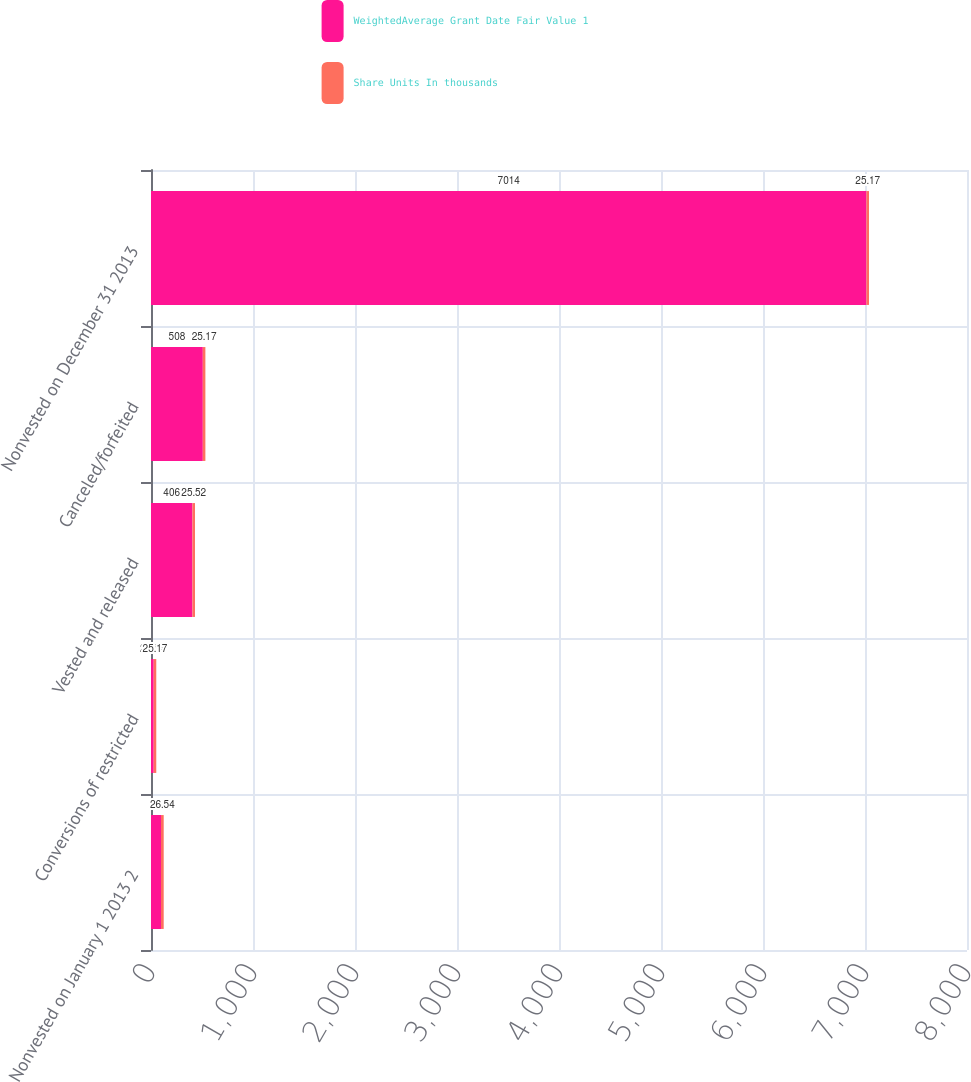Convert chart to OTSL. <chart><loc_0><loc_0><loc_500><loc_500><stacked_bar_chart><ecel><fcel>Nonvested on January 1 2013 2<fcel>Conversions of restricted<fcel>Vested and released<fcel>Canceled/forfeited<fcel>Nonvested on December 31 2013<nl><fcel>WeightedAverage Grant Date Fair Value 1<fcel>98<fcel>26.54<fcel>406<fcel>508<fcel>7014<nl><fcel>Share Units In thousands<fcel>26.54<fcel>25.17<fcel>25.52<fcel>25.17<fcel>25.17<nl></chart> 